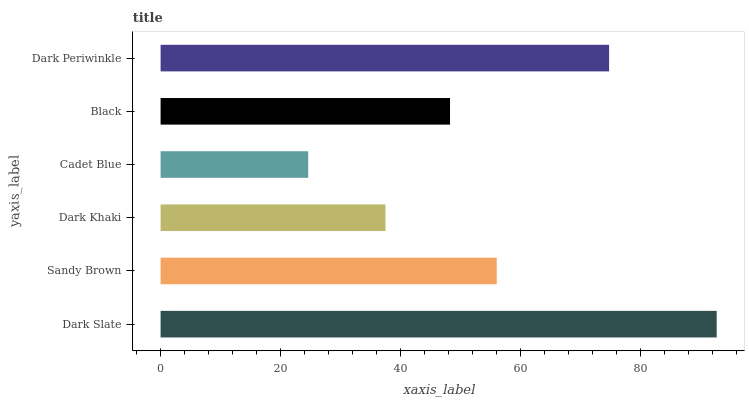Is Cadet Blue the minimum?
Answer yes or no. Yes. Is Dark Slate the maximum?
Answer yes or no. Yes. Is Sandy Brown the minimum?
Answer yes or no. No. Is Sandy Brown the maximum?
Answer yes or no. No. Is Dark Slate greater than Sandy Brown?
Answer yes or no. Yes. Is Sandy Brown less than Dark Slate?
Answer yes or no. Yes. Is Sandy Brown greater than Dark Slate?
Answer yes or no. No. Is Dark Slate less than Sandy Brown?
Answer yes or no. No. Is Sandy Brown the high median?
Answer yes or no. Yes. Is Black the low median?
Answer yes or no. Yes. Is Dark Khaki the high median?
Answer yes or no. No. Is Dark Periwinkle the low median?
Answer yes or no. No. 